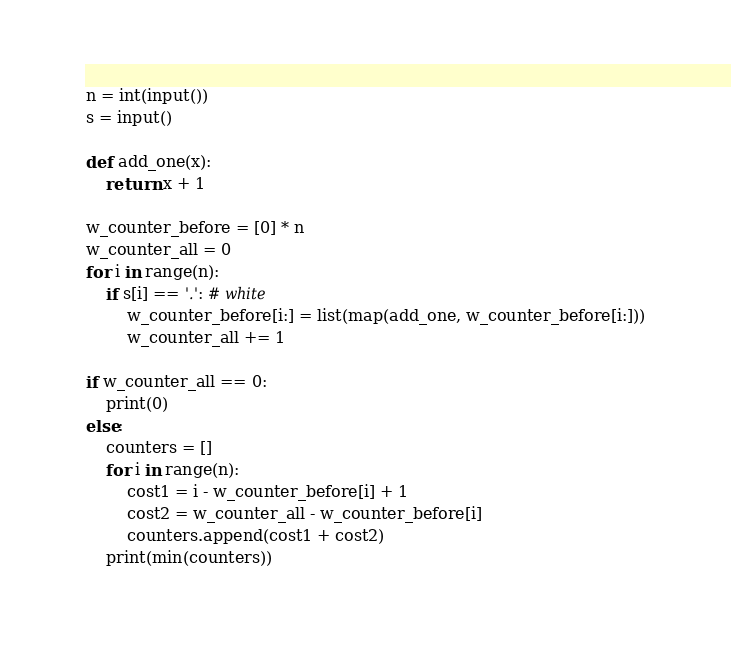Convert code to text. <code><loc_0><loc_0><loc_500><loc_500><_Python_>n = int(input())
s = input()

def add_one(x):
    return x + 1

w_counter_before = [0] * n
w_counter_all = 0
for i in range(n):
    if s[i] == '.': # white
        w_counter_before[i:] = list(map(add_one, w_counter_before[i:]))
        w_counter_all += 1

if w_counter_all == 0:
    print(0)
else:
    counters = []
    for i in range(n):
        cost1 = i - w_counter_before[i] + 1
        cost2 = w_counter_all - w_counter_before[i]
        counters.append(cost1 + cost2)
    print(min(counters))
</code> 